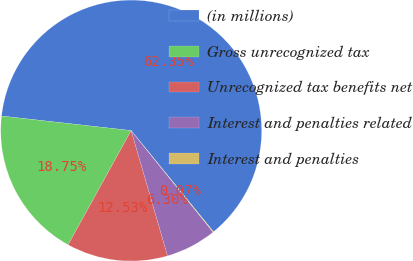Convert chart to OTSL. <chart><loc_0><loc_0><loc_500><loc_500><pie_chart><fcel>(in millions)<fcel>Gross unrecognized tax<fcel>Unrecognized tax benefits net<fcel>Interest and penalties related<fcel>Interest and penalties<nl><fcel>62.35%<fcel>18.75%<fcel>12.53%<fcel>6.3%<fcel>0.07%<nl></chart> 